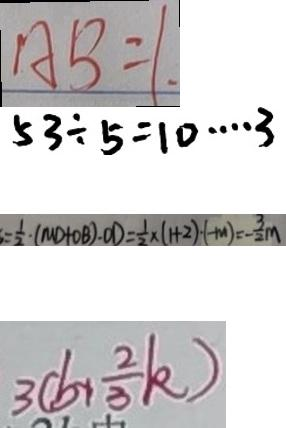Convert formula to latex. <formula><loc_0><loc_0><loc_500><loc_500>A B = 1 . 
 5 3 \div 5 = 1 0 \cdots 3 
 = \frac { 1 } { 2 } \cdot ( M D + O B ) \cdot O D = \frac { 1 } { 2 } \times ( 1 + 2 ) \cdot ( - m ) = - \frac { 3 } { 2 } m 
 3 ( b + \frac { 2 } { 3 } k )</formula> 